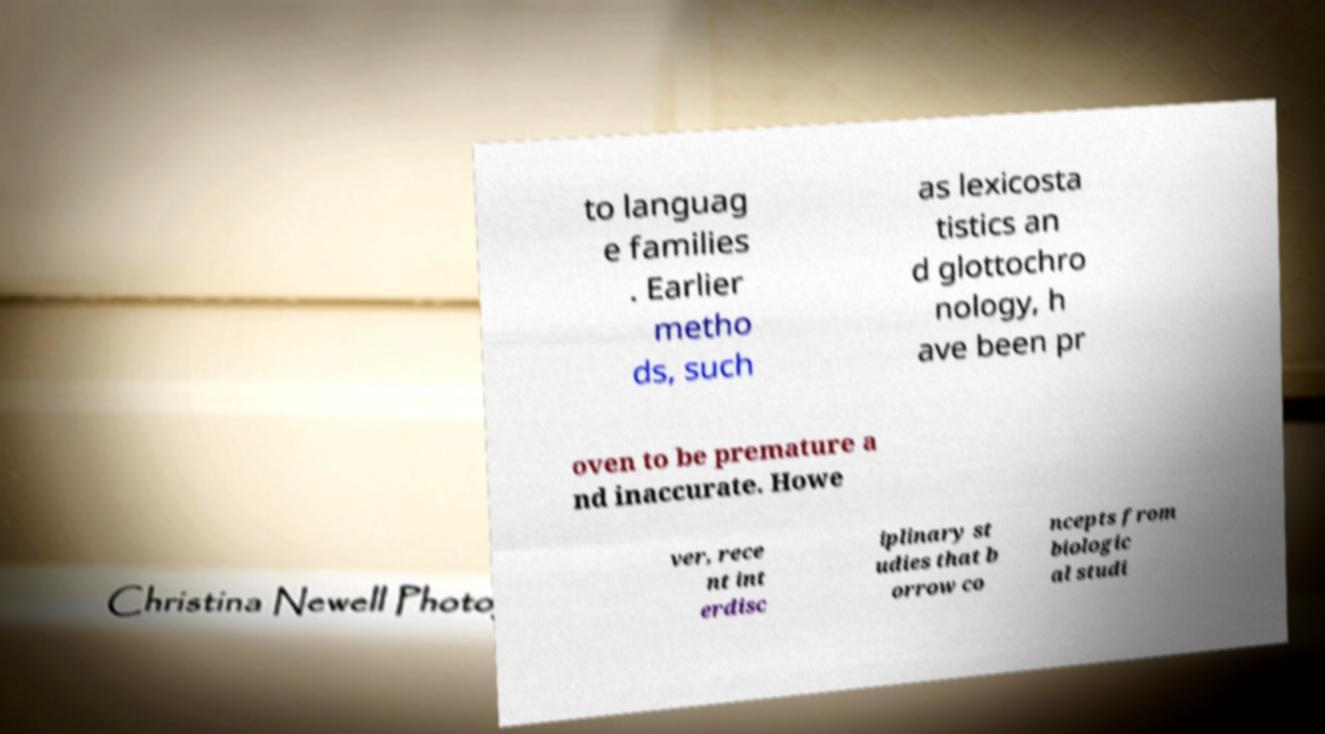Please read and relay the text visible in this image. What does it say? to languag e families . Earlier metho ds, such as lexicosta tistics an d glottochro nology, h ave been pr oven to be premature a nd inaccurate. Howe ver, rece nt int erdisc iplinary st udies that b orrow co ncepts from biologic al studi 